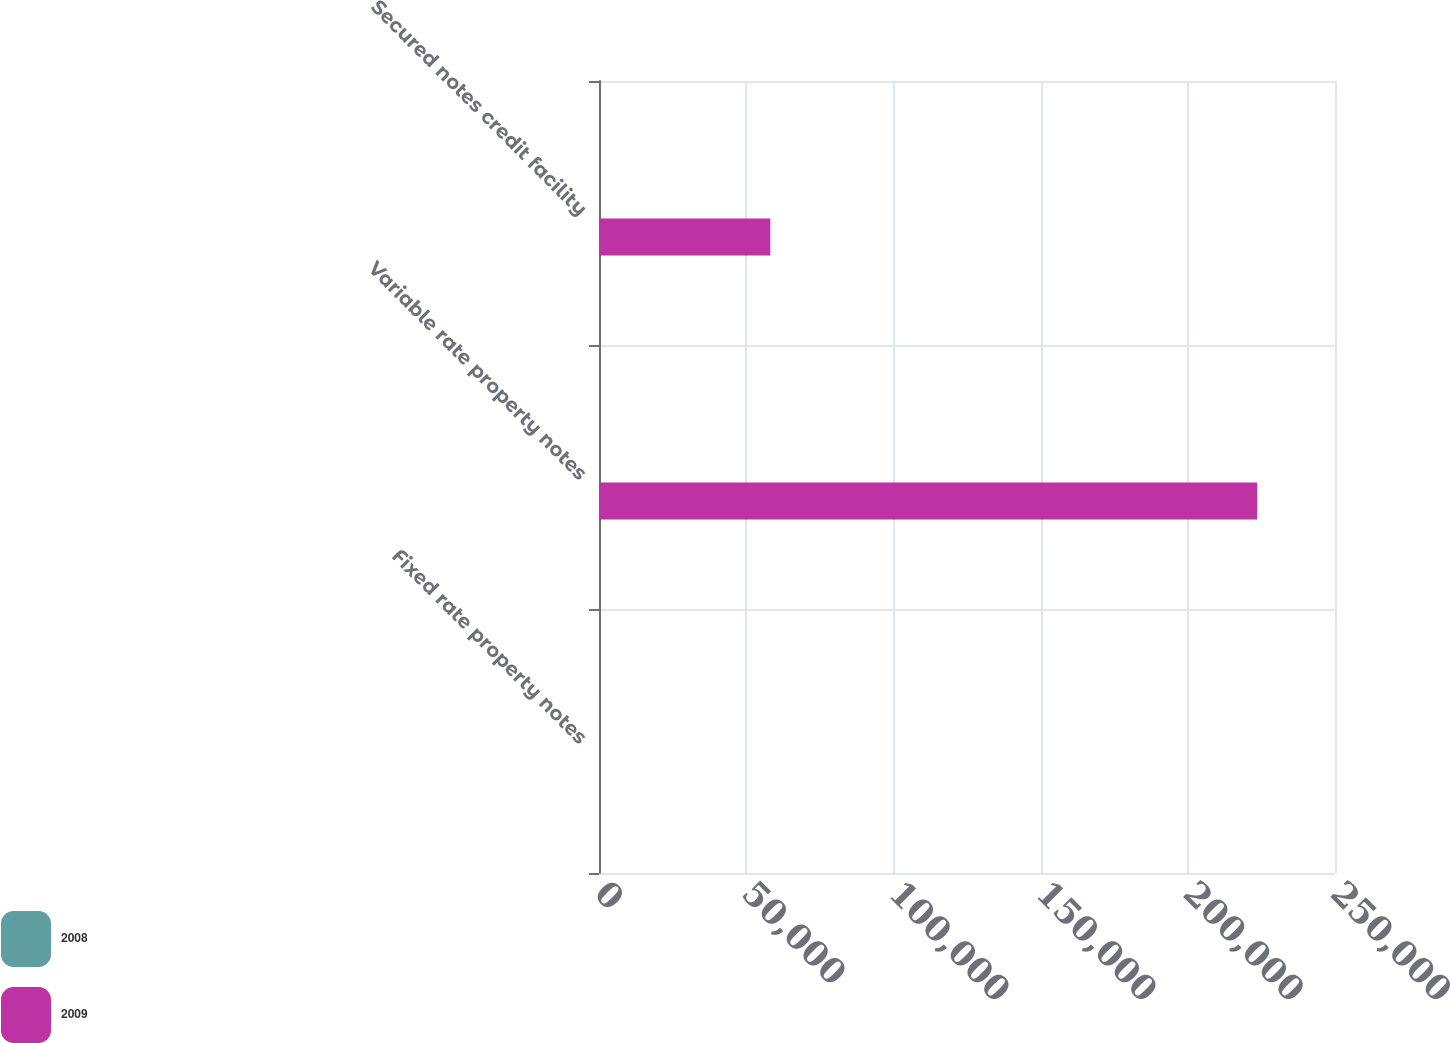Convert chart. <chart><loc_0><loc_0><loc_500><loc_500><stacked_bar_chart><ecel><fcel>Fixed rate property notes<fcel>Variable rate property notes<fcel>Secured notes credit facility<nl><fcel>2008<fcel>6.01<fcel>2.46<fcel>1.02<nl><fcel>2009<fcel>6.01<fcel>223561<fcel>58179<nl></chart> 